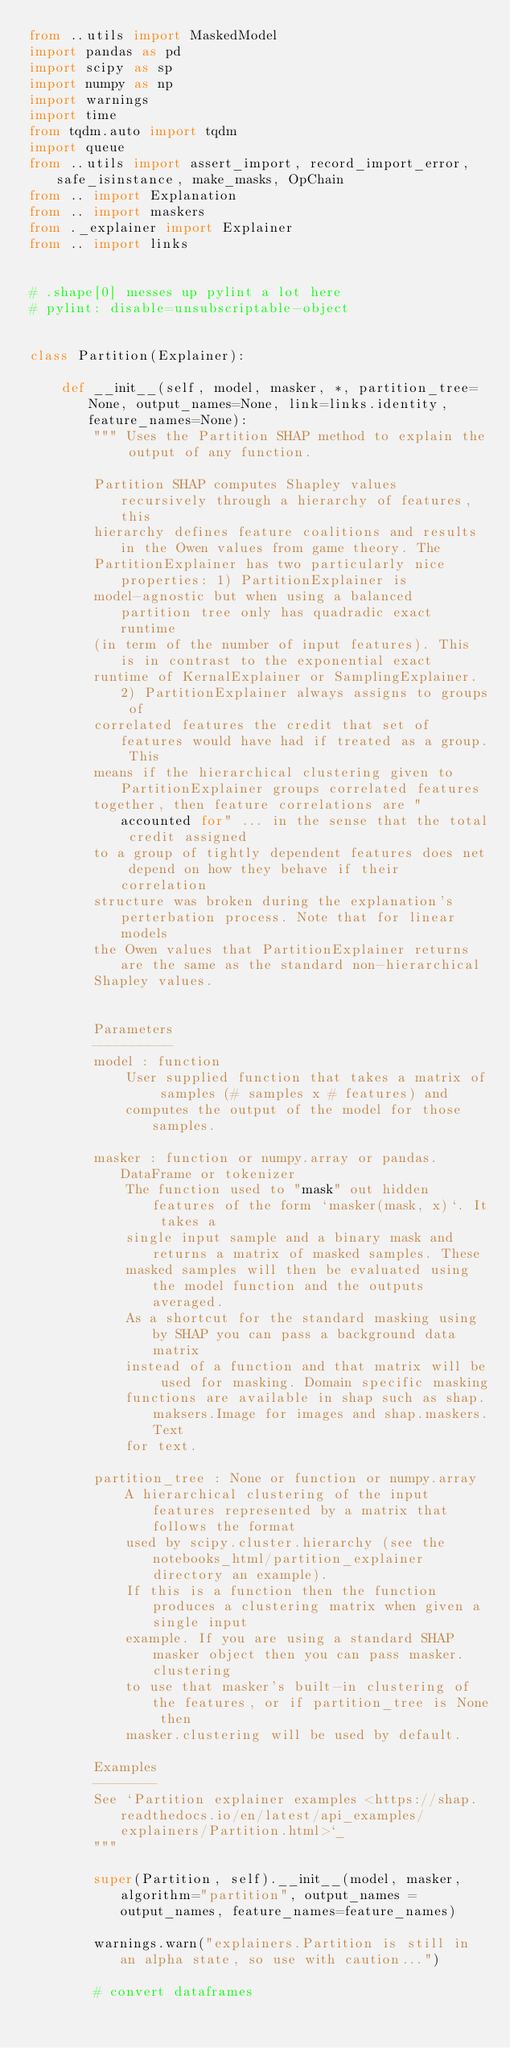<code> <loc_0><loc_0><loc_500><loc_500><_Python_>from ..utils import MaskedModel
import pandas as pd
import scipy as sp
import numpy as np
import warnings
import time
from tqdm.auto import tqdm
import queue
from ..utils import assert_import, record_import_error, safe_isinstance, make_masks, OpChain
from .. import Explanation
from .. import maskers
from ._explainer import Explainer
from .. import links


# .shape[0] messes up pylint a lot here
# pylint: disable=unsubscriptable-object


class Partition(Explainer):
    
    def __init__(self, model, masker, *, partition_tree=None, output_names=None, link=links.identity, feature_names=None):
        """ Uses the Partition SHAP method to explain the output of any function.

        Partition SHAP computes Shapley values recursively through a hierarchy of features, this
        hierarchy defines feature coalitions and results in the Owen values from game theory. The
        PartitionExplainer has two particularly nice properties: 1) PartitionExplainer is
        model-agnostic but when using a balanced partition tree only has quadradic exact runtime 
        (in term of the number of input features). This is in contrast to the exponential exact
        runtime of KernalExplainer or SamplingExplainer. 2) PartitionExplainer always assigns to groups of
        correlated features the credit that set of features would have had if treated as a group. This
        means if the hierarchical clustering given to PartitionExplainer groups correlated features
        together, then feature correlations are "accounted for" ... in the sense that the total credit assigned
        to a group of tightly dependent features does net depend on how they behave if their correlation
        structure was broken during the explanation's perterbation process. Note that for linear models
        the Owen values that PartitionExplainer returns are the same as the standard non-hierarchical
        Shapley values.


        Parameters
        ----------
        model : function
            User supplied function that takes a matrix of samples (# samples x # features) and
            computes the output of the model for those samples.

        masker : function or numpy.array or pandas.DataFrame or tokenizer
            The function used to "mask" out hidden features of the form `masker(mask, x)`. It takes a
            single input sample and a binary mask and returns a matrix of masked samples. These
            masked samples will then be evaluated using the model function and the outputs averaged.
            As a shortcut for the standard masking using by SHAP you can pass a background data matrix
            instead of a function and that matrix will be used for masking. Domain specific masking
            functions are available in shap such as shap.maksers.Image for images and shap.maskers.Text
            for text.

        partition_tree : None or function or numpy.array
            A hierarchical clustering of the input features represented by a matrix that follows the format
            used by scipy.cluster.hierarchy (see the notebooks_html/partition_explainer directory an example).
            If this is a function then the function produces a clustering matrix when given a single input
            example. If you are using a standard SHAP masker object then you can pass masker.clustering
            to use that masker's built-in clustering of the features, or if partition_tree is None then
            masker.clustering will be used by default.
        
        Examples
        --------
        See `Partition explainer examples <https://shap.readthedocs.io/en/latest/api_examples/explainers/Partition.html>`_
        """

        super(Partition, self).__init__(model, masker, algorithm="partition", output_names = output_names, feature_names=feature_names)
        
        warnings.warn("explainers.Partition is still in an alpha state, so use with caution...")
        
        # convert dataframes</code> 